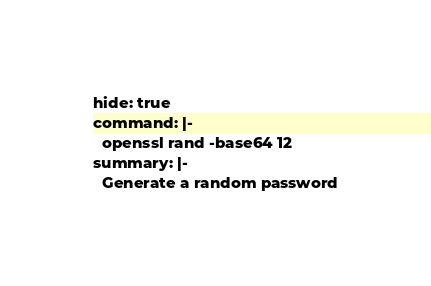Convert code to text. <code><loc_0><loc_0><loc_500><loc_500><_YAML_>hide: true
command: |-
  openssl rand -base64 12
summary: |-
  Generate a random password
</code> 